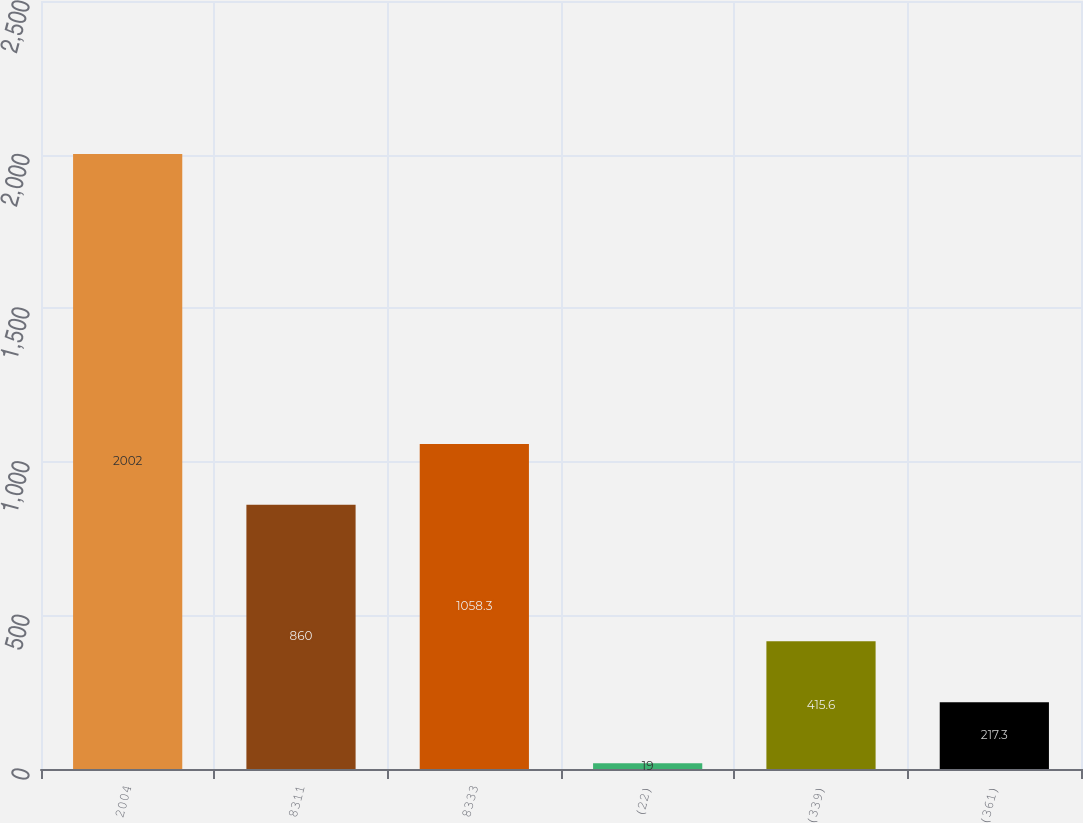<chart> <loc_0><loc_0><loc_500><loc_500><bar_chart><fcel>2004<fcel>8311<fcel>8333<fcel>(22)<fcel>(339)<fcel>(361)<nl><fcel>2002<fcel>860<fcel>1058.3<fcel>19<fcel>415.6<fcel>217.3<nl></chart> 